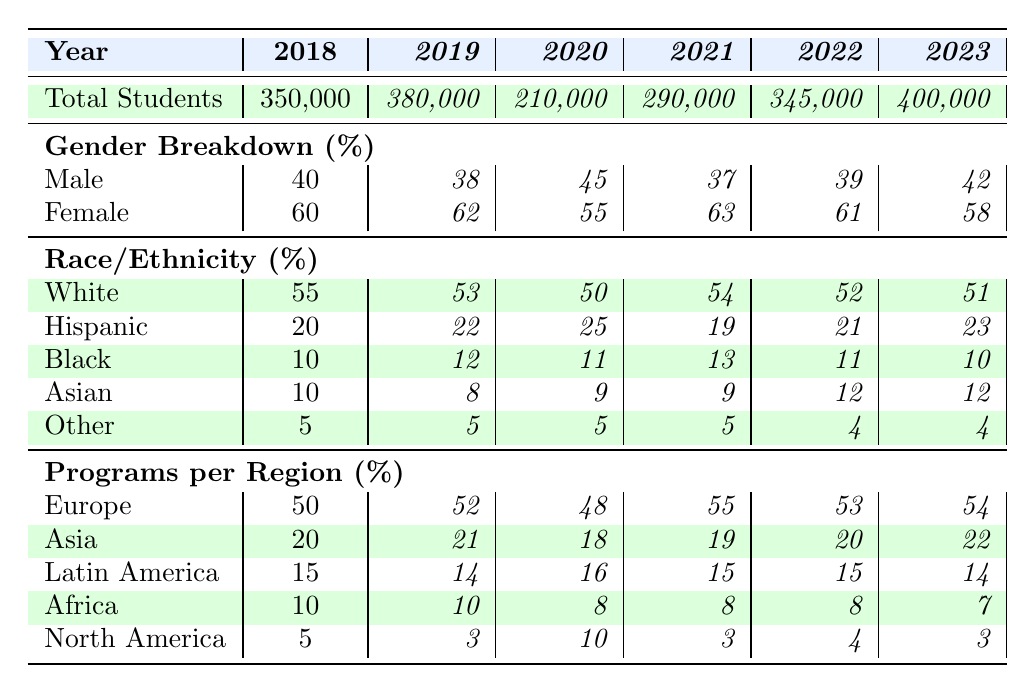What is the total number of students in 2021? Referring to the table, the total number of students for the year 2021 is listed in the "Total Students" row under that year. It states 290,000.
Answer: 290,000 In which year did the highest number of students participate in study abroad programs? Looking at the "Total Students" row, I note the highest value is 400,000 in 2023, which is greater than all the other years.
Answer: 2023 What percentage of students were male in 2019? The table indicates the male percentage for 2019 in the "Gender Breakdown" section, which shows 38%.
Answer: 38% How many total students were there in 2020 compared to 2018? From the table, 2020 had 210,000 students and 2018 had 350,000 students. The difference is 350,000 - 210,000 = 140,000, meaning 2020 had 140,000 fewer students than 2018.
Answer: 140,000 What is the average percentage of Hispanic students from 2018 to 2023? Adding the percentage of Hispanic students from each year: 20% + 22% + 25% + 19% + 21% + 23% = 130%. There are 6 data points, so averaging gives 130% / 6 = approximately 21.67%.
Answer: 21.67% Was the percentage of female students greater than the percentage of male students in all years? Comparing the "Gender Breakdown" percentages for each year, in every year, female students are more than male students: 60% vs 40% in 2018, 62% vs 38% in 2019, etc. This confirms yes, female students were greater throughout.
Answer: Yes Which region saw the highest percentage of programs in 2021? Checking the "Programs per Region" for 2021, Europe had the highest percentage at 55%, which is higher than all other regions listed.
Answer: Europe How did the total number of students change from 2022 to 2023? The total students for 2022 were 345,000 and for 2023 they were 400,000, so the change is 400,000 - 345,000 = 55,000 more students in 2023.
Answer: 55,000 What is the difference in percentage of Asian students from 2018 to 2023? From the "Race/Ethnicity" section, Asian students were 10% in 2018 and 12% in 2023. The difference is 12% - 10% = 2%.
Answer: 2% In what year was the percentage of Black students highest? Evaluating the "Race/Ethnicity" section, the highest percentage of Black students is 13% in 2021, compared to all other years.
Answer: 2021 What percentage of students studied in North America in 2020? The table states that the percentage of students studying in North America in 2020 is 10%.
Answer: 10% 